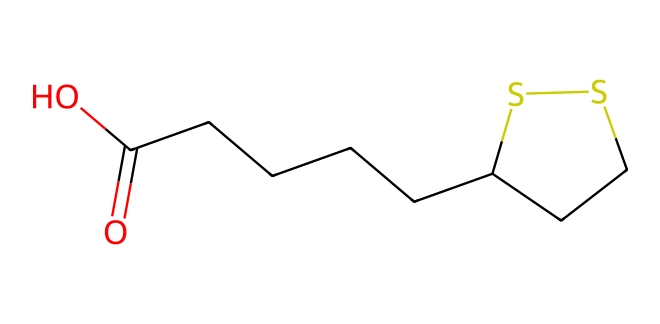How many sulfur (S) atoms are present in this molecule? The SMILES representation reveals the presence of "S" two times in the structure, indicating that there are two sulfur atoms in the molecule.
Answer: two What is the molecular formula of lipoic acid derived from the SMILES? By interpreting the SMILES, there are 8 carbon (C) atoms, 14 hydrogen (H) atoms, 2 oxygen (O) atoms, and 2 sulfur (S) atoms, leading to the molecular formula C8H14O2S2.
Answer: C8H14O2S2 What functional groups are present in this molecule? The SMILES indicates a carboxylic acid group (due to "O=C(O)") and a thioether group (due to the presence of sulfur atoms in a ring), revealing these functional groups.
Answer: carboxylic acid, thioether What type of chemical structure is lipoic acid classified as? Analyzing the SMILES shows the presence of sulfur and carbon atoms in the structure, categorizing it as an organosulfur compound.
Answer: organosulfur compound Does lipoic acid have any chiral centers? In examining the structure, the absence of any asymmetric carbon atoms indicates that lipoic acid does not have chiral centers.
Answer: no What is the primary role of lipoic acid in secure ink formulations? Considering the properties of lipoic acid as an antioxidant, it is utilized in secure ink formulations to provide stability and protection against oxidative degradation of the inks.
Answer: antioxidant 